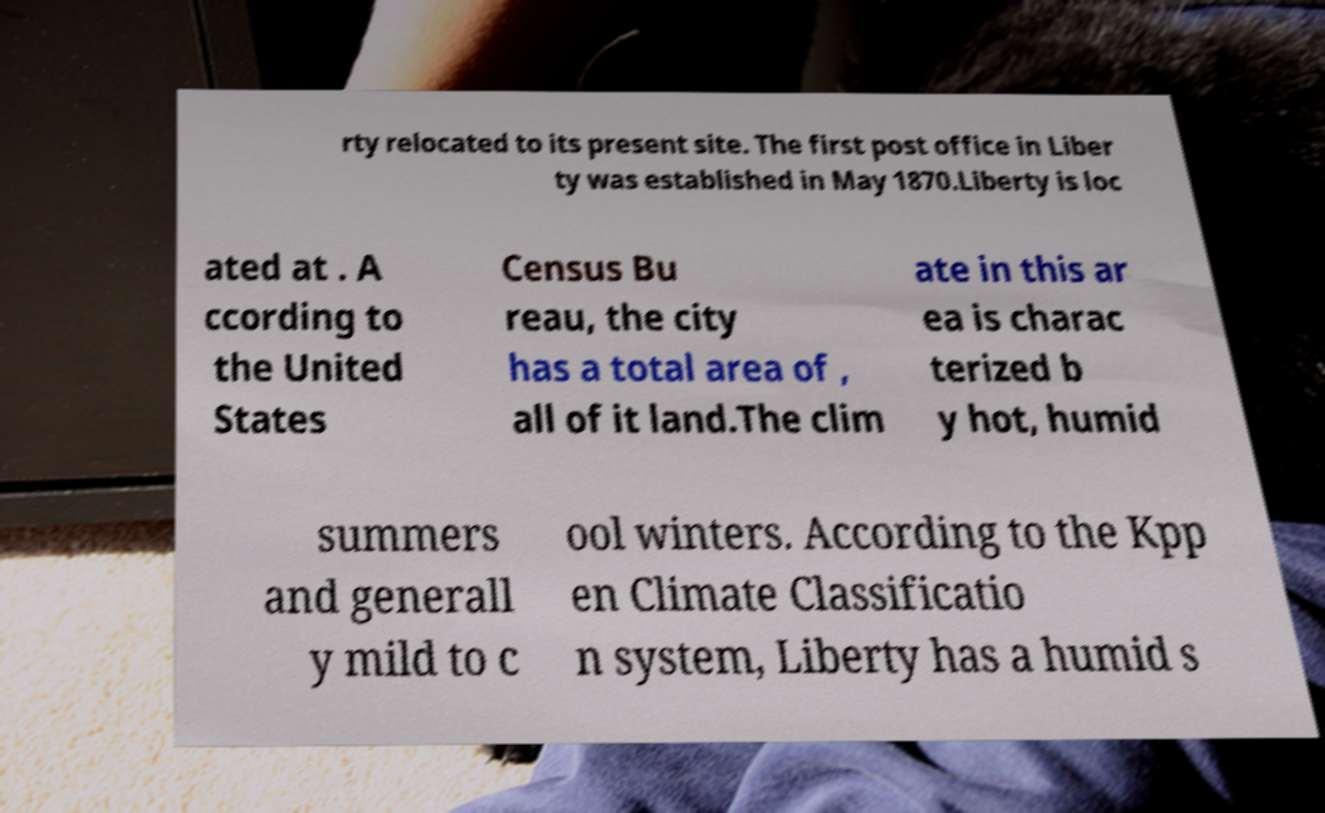Could you assist in decoding the text presented in this image and type it out clearly? rty relocated to its present site. The first post office in Liber ty was established in May 1870.Liberty is loc ated at . A ccording to the United States Census Bu reau, the city has a total area of , all of it land.The clim ate in this ar ea is charac terized b y hot, humid summers and generall y mild to c ool winters. According to the Kpp en Climate Classificatio n system, Liberty has a humid s 